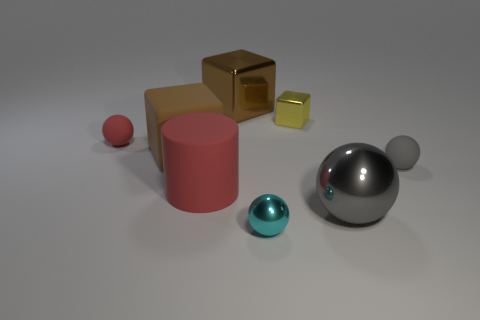What material do the objects seem to be made of? Based on their appearance, the objects could be made of various materials: the spheres and the cubes have a metallic sheen suggesting they could be made of metal, while the cylinder's matte finish might indicate a different composition, perhaps plastic or ceramic. 